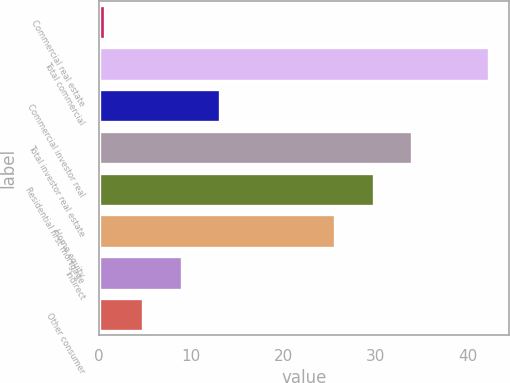<chart> <loc_0><loc_0><loc_500><loc_500><bar_chart><fcel>Commercial real estate<fcel>Total commercial<fcel>Commercial investor real<fcel>Total investor real estate<fcel>Residential first mortgage<fcel>Home equity<fcel>Indirect<fcel>Other consumer<nl><fcel>0.6<fcel>42.3<fcel>13.11<fcel>33.96<fcel>29.79<fcel>25.62<fcel>8.94<fcel>4.77<nl></chart> 